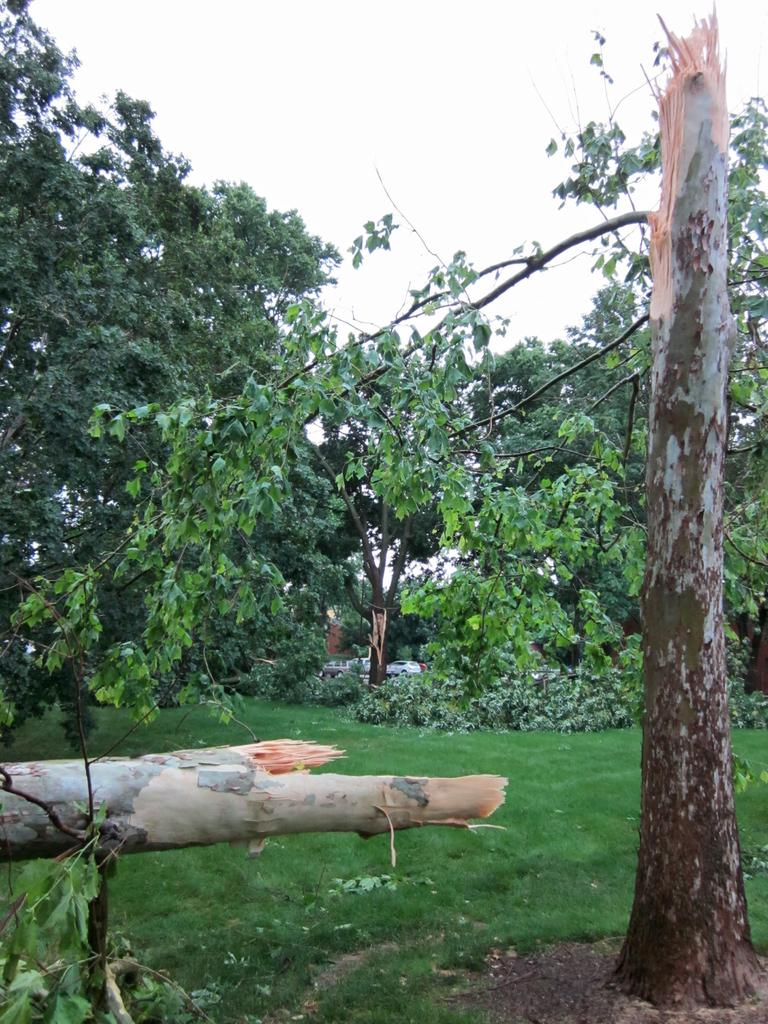What type of vegetation is visible in the image? There is a lot of greenery in the image, including tall trees, plants, and grass. Where is the faucet located in the image? There is no faucet present in the image. Can you tell me the name of the sister who is also in the image? There is no reference to a sister or any people in the image, so it's not possible to answer that question. 